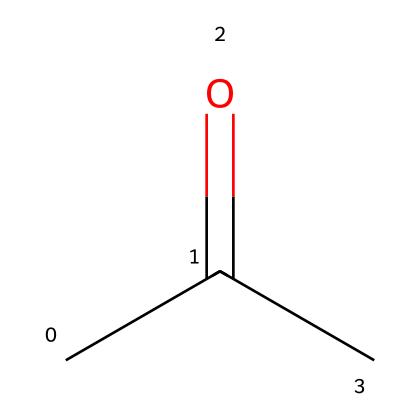What is the molecular formula of this compound? The SMILES representation CC(=O)C indicates that it consists of three carbon (C) atoms, six hydrogen (H) atoms, and one oxygen (O) atom. Therefore, the molecular formula is derived as C3H6O.
Answer: C3H6O How many carbon atoms are present in the structure? Looking at the SMILES representation CC(=O)C, we can count the carbon atoms present: there are three individual carbon elements noted in the chain and functional group, leading to a total of three.
Answer: 3 What is the functional group in this compound? The SMILES representation shows the presence of the carbonyl group (C=O) attached to a carbon atom, which categorizes this compound as a ketone. Thus, the functional group is specifically the carbonyl (C=O).
Answer: carbonyl What type of carbonyl compound is represented? Since the carbonyl group (C=O) is located between two carbon atoms, this places the compound in the ketone category, indicating it is a ketone rather than an aldehyde or other type.
Answer: ketone How many total hydrogen atoms are present in this structure? From the SMILES CC(=O)C, we deduce that there are six hydrogen atoms linked to the three carbon atoms. In this representation, the saturation of the carbon atoms combined with the positioning of the functional group reveals the total number of hydrogen atoms to be six.
Answer: 6 What historical industrial application significantly used this compound? Acetone, the compound represented by the SMILES, was prominently used as a solvent in the manufacturing process of plastics and fibers during the Industrial Revolution, aiding in the production of materials such as rayon and other synthetics.
Answer: solvent 